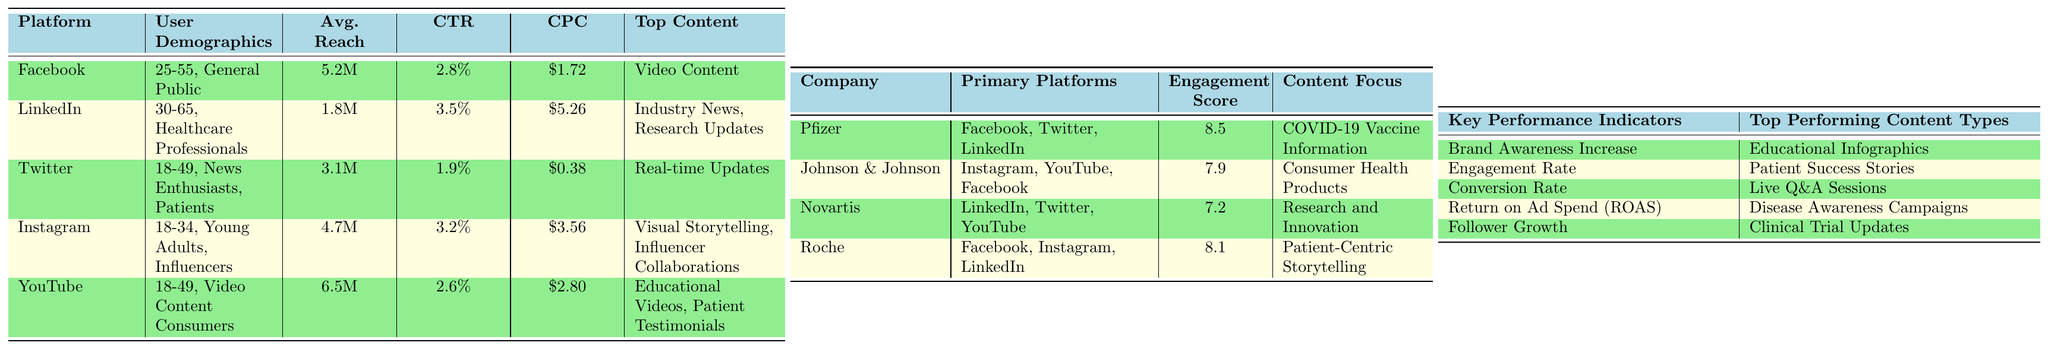What is the average reach of Facebook and Instagram combined? The average reach for Facebook is 5.2 million and for Instagram is 4.7 million. By summing these values, we get (5.2 + 4.7) = 9.9 million. To find the average, we divide by 2, resulting in 9.9 million / 2 = 4.95 million.
Answer: 4.95 million Which platform has the highest click-through rate (CTR)? The click-through rates are: Facebook at 2.8%, LinkedIn at 3.5%, Twitter at 1.9%, Instagram at 3.2%, and YouTube at 2.6%. The highest is LinkedIn with 3.5%.
Answer: LinkedIn Is the cost per click (CPC) for Twitter lower than that of Facebook? The CPC for Twitter is $0.38 and for Facebook is $1.72. Since $0.38 is less than $1.72, the statement is true.
Answer: Yes Which platform is focused on healthcare professionals? The user demographics for LinkedIn state that its primary audience is healthcare professionals.
Answer: LinkedIn What is the engagement score of Roche? The engagement score for Roche listed in the competitor analysis table is 8.1.
Answer: 8.1 If we compare the click-through rates, which platform has the lowest CTR? The click-through rates are: Facebook at 2.8%, LinkedIn at 3.5%, Twitter at 1.9%, Instagram at 3.2%, and YouTube at 2.6%. The lowest is Twitter at 1.9%.
Answer: Twitter How many top-performing content types are listed? The table lists five top-performing content types: Educational Infographics, Patient Success Stories, Live Q&A Sessions, Disease Awareness Campaigns, and Clinical Trial Updates. Therefore, the total is five.
Answer: 5 Which company has the highest engagement score, and what is its primary content focus? The highest engagement score is 8.5, belonging to Pfizer, which focuses on COVID-19 Vaccine Information.
Answer: Pfizer, COVID-19 Vaccine Information What is the average age range of users on Instagram? The user demographic for Instagram has an age range of 18-34 years.
Answer: 18-34 If you were to rank the platforms based on average reach from highest to lowest, which platform would fall in the second position? The average reaches are: YouTube (6.5M), Facebook (5.2M), Instagram (4.7M), Twitter (3.1M), and LinkedIn (1.8M). Ranking them, YouTube is first, and Facebook is second.
Answer: Facebook 